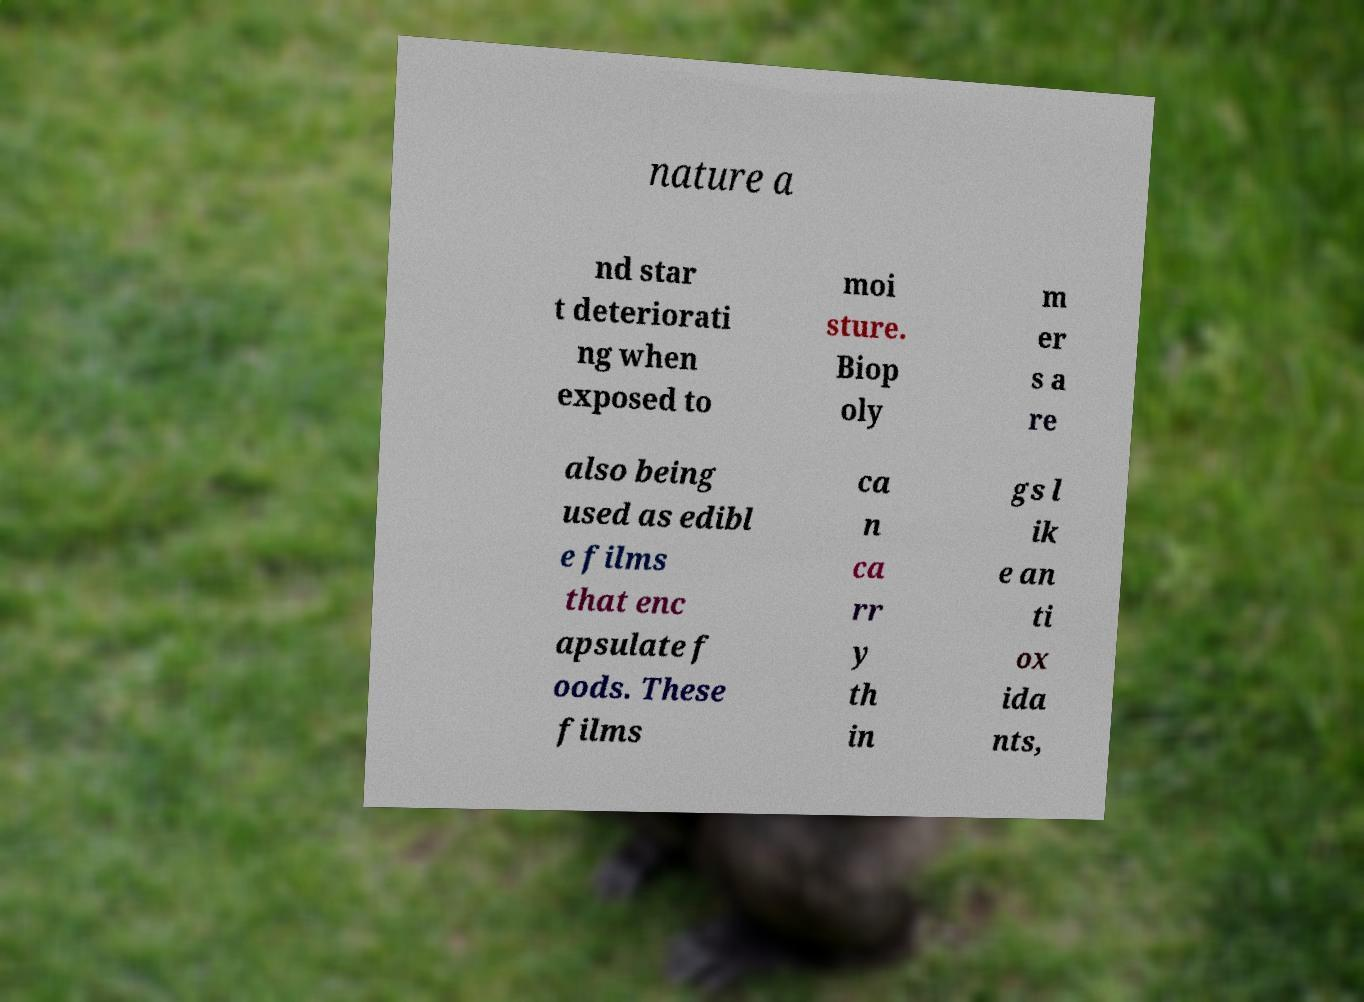There's text embedded in this image that I need extracted. Can you transcribe it verbatim? nature a nd star t deteriorati ng when exposed to moi sture. Biop oly m er s a re also being used as edibl e films that enc apsulate f oods. These films ca n ca rr y th in gs l ik e an ti ox ida nts, 